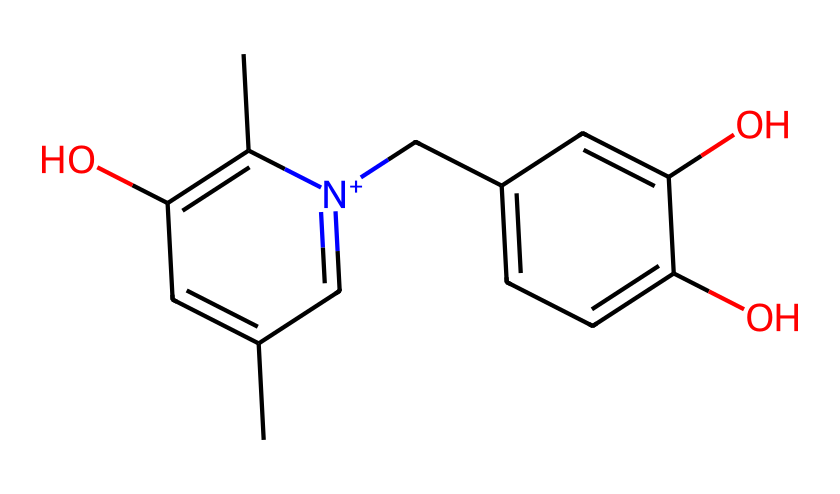How many carbon atoms are in this compound? By analyzing the SMILES representation, we can count the number of 'C' characters present, which indicate carbon atoms. Each carbon atom in the structure corresponds to a visual element in the rendered model of the molecule. In this case, there are 15 carbon atoms in total.
Answer: 15 What is the functional group present in this chemical? The presence of the hydroxyl (-OH) groups indicates that this chemical exhibits alcohol functional groups. In the SMILES, the 'O' indicates the location of the hydroxyl groups attached to the carbon atoms in the ring structures.
Answer: alcohol Does this compound contain any nitrogen atoms? In the SMILES representation, there is one occurrence of 'n,' which denotes the presence of a nitrogen atom in the structure. Nitrogen is typically associated with properties that could also enhance the therapeutic action of the compound.
Answer: yes What is the total number of hydroxyl groups in this molecule? We can identify hydroxyl groups by looking for the 'O' character in the SMILES representation followed by a hydrogen atom. Upon inspection, we see three -OH groups in the structure of this compound.
Answer: 3 Is this compound likely to be used as an antiseptic? Given the presence of multiple hydroxyl groups and the aromatic rings in the structure, which are common in many antiseptics, this compound is likely to have antiseptic properties. The strong electron-donating capabilities and the structural characteristics support its efficacy.
Answer: yes Which part of this chemical is responsible for its antiseptic properties? The multiple hydroxyl groups present in the structure of this compound enhance its ability to disrupt bacterial cell membranes and confer antiseptic properties. The arrangement of these groups around the aromatic structure may also play a role in increasing biochemical interactions.
Answer: hydroxyl groups What type of bonding predominates in this chemical? The predominant type of bonding in this structure is covalent bonding between the carbon and oxygen atoms, as indicated by the SMILES notation, where atoms are shared among the elements in the molecular frames. The rings and branches signify strong covalent linkages throughout the compound.
Answer: covalent bonding 